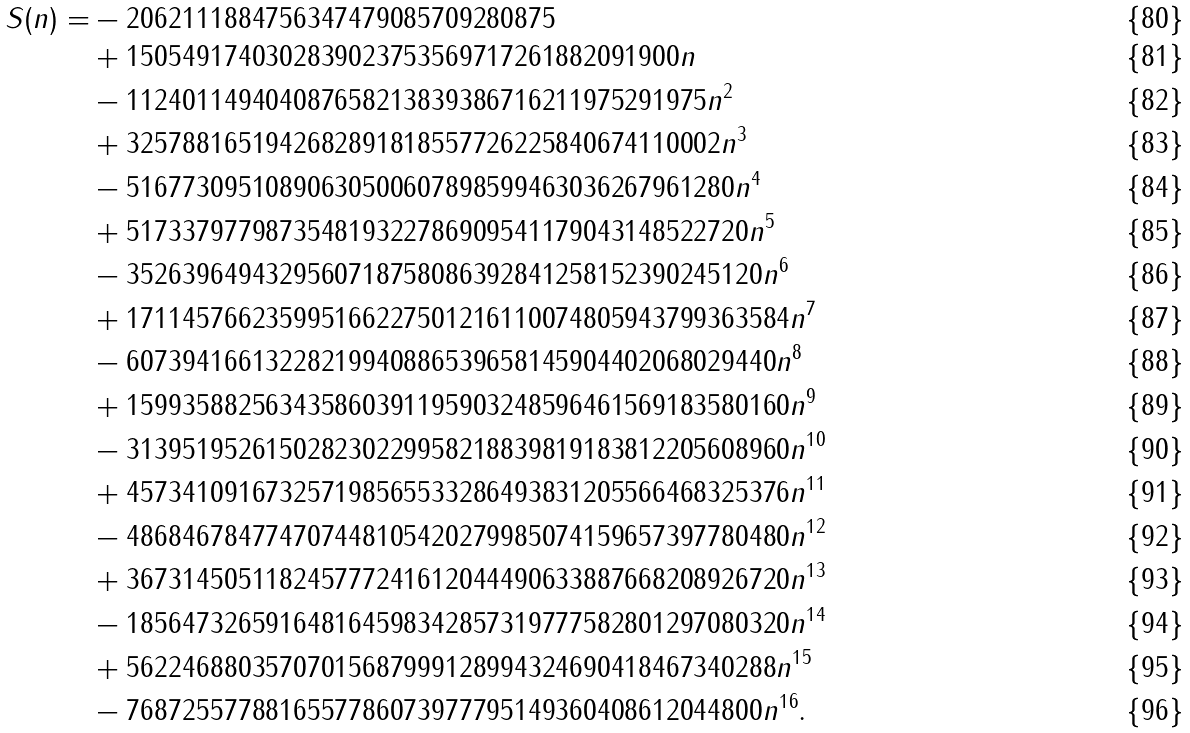Convert formula to latex. <formula><loc_0><loc_0><loc_500><loc_500>S ( n ) = & - 2 0 6 2 1 1 1 8 8 4 7 5 6 3 4 7 4 7 9 0 8 5 7 0 9 2 8 0 8 7 5 \\ & + 1 5 0 5 4 9 1 7 4 0 3 0 2 8 3 9 0 2 3 7 5 3 5 6 9 7 1 7 2 6 1 8 8 2 0 9 1 9 0 0 n \\ & - 1 1 2 4 0 1 1 4 9 4 0 4 0 8 7 6 5 8 2 1 3 8 3 9 3 8 6 7 1 6 2 1 1 9 7 5 2 9 1 9 7 5 n ^ { 2 } \\ & + 3 2 5 7 8 8 1 6 5 1 9 4 2 6 8 2 8 9 1 8 1 8 5 5 7 7 2 6 2 2 5 8 4 0 6 7 4 1 1 0 0 0 2 n ^ { 3 } \\ & - 5 1 6 7 7 3 0 9 5 1 0 8 9 0 6 3 0 5 0 0 6 0 7 8 9 8 5 9 9 4 6 3 0 3 6 2 6 7 9 6 1 2 8 0 n ^ { 4 } \\ & + 5 1 7 3 3 7 9 7 7 9 8 7 3 5 4 8 1 9 3 2 2 7 8 6 9 0 9 5 4 1 1 7 9 0 4 3 1 4 8 5 2 2 7 2 0 n ^ { 5 } \\ & - 3 5 2 6 3 9 6 4 9 4 3 2 9 5 6 0 7 1 8 7 5 8 0 8 6 3 9 2 8 4 1 2 5 8 1 5 2 3 9 0 2 4 5 1 2 0 n ^ { 6 } \\ & + 1 7 1 1 4 5 7 6 6 2 3 5 9 9 5 1 6 6 2 2 7 5 0 1 2 1 6 1 1 0 0 7 4 8 0 5 9 4 3 7 9 9 3 6 3 5 8 4 n ^ { 7 } \\ & - 6 0 7 3 9 4 1 6 6 1 3 2 2 8 2 1 9 9 4 0 8 8 6 5 3 9 6 5 8 1 4 5 9 0 4 4 0 2 0 6 8 0 2 9 4 4 0 n ^ { 8 } \\ & + 1 5 9 9 3 5 8 8 2 5 6 3 4 3 5 8 6 0 3 9 1 1 9 5 9 0 3 2 4 8 5 9 6 4 6 1 5 6 9 1 8 3 5 8 0 1 6 0 n ^ { 9 } \\ & - 3 1 3 9 5 1 9 5 2 6 1 5 0 2 8 2 3 0 2 2 9 9 5 8 2 1 8 8 3 9 8 1 9 1 8 3 8 1 2 2 0 5 6 0 8 9 6 0 n ^ { 1 0 } \\ & + 4 5 7 3 4 1 0 9 1 6 7 3 2 5 7 1 9 8 5 6 5 5 3 3 2 8 6 4 9 3 8 3 1 2 0 5 5 6 6 4 6 8 3 2 5 3 7 6 n ^ { 1 1 } \\ & - 4 8 6 8 4 6 7 8 4 7 7 4 7 0 7 4 4 8 1 0 5 4 2 0 2 7 9 9 8 5 0 7 4 1 5 9 6 5 7 3 9 7 7 8 0 4 8 0 n ^ { 1 2 } \\ & + 3 6 7 3 1 4 5 0 5 1 1 8 2 4 5 7 7 7 2 4 1 6 1 2 0 4 4 4 9 0 6 3 3 8 8 7 6 6 8 2 0 8 9 2 6 7 2 0 n ^ { 1 3 } \\ & - 1 8 5 6 4 7 3 2 6 5 9 1 6 4 8 1 6 4 5 9 8 3 4 2 8 5 7 3 1 9 7 7 7 5 8 2 8 0 1 2 9 7 0 8 0 3 2 0 n ^ { 1 4 } \\ & + 5 6 2 2 4 6 8 8 0 3 5 7 0 7 0 1 5 6 8 7 9 9 9 1 2 8 9 9 4 3 2 4 6 9 0 4 1 8 4 6 7 3 4 0 2 8 8 n ^ { 1 5 } \\ & - 7 6 8 7 2 5 5 7 7 8 8 1 6 5 5 7 7 8 6 0 7 3 9 7 7 7 9 5 1 4 9 3 6 0 4 0 8 6 1 2 0 4 4 8 0 0 n ^ { 1 6 } .</formula> 